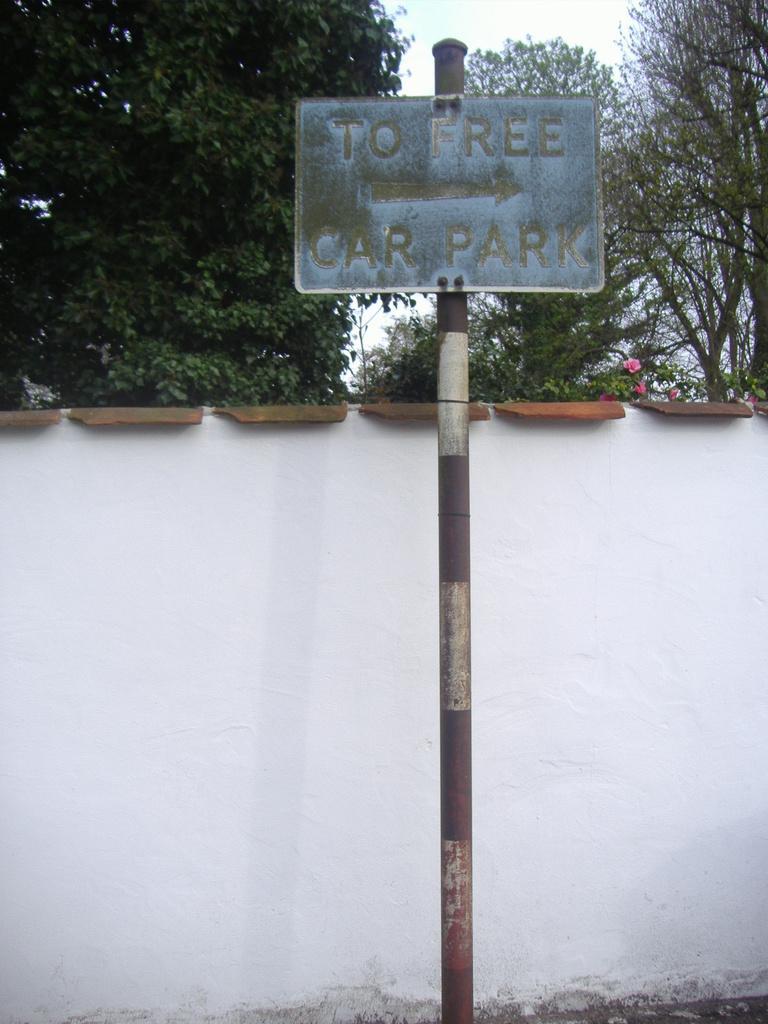In one or two sentences, can you explain what this image depicts? In this image at the center there is a sign board. On the backside of the image there is a wall. In the background of the image there are trees and sky. 